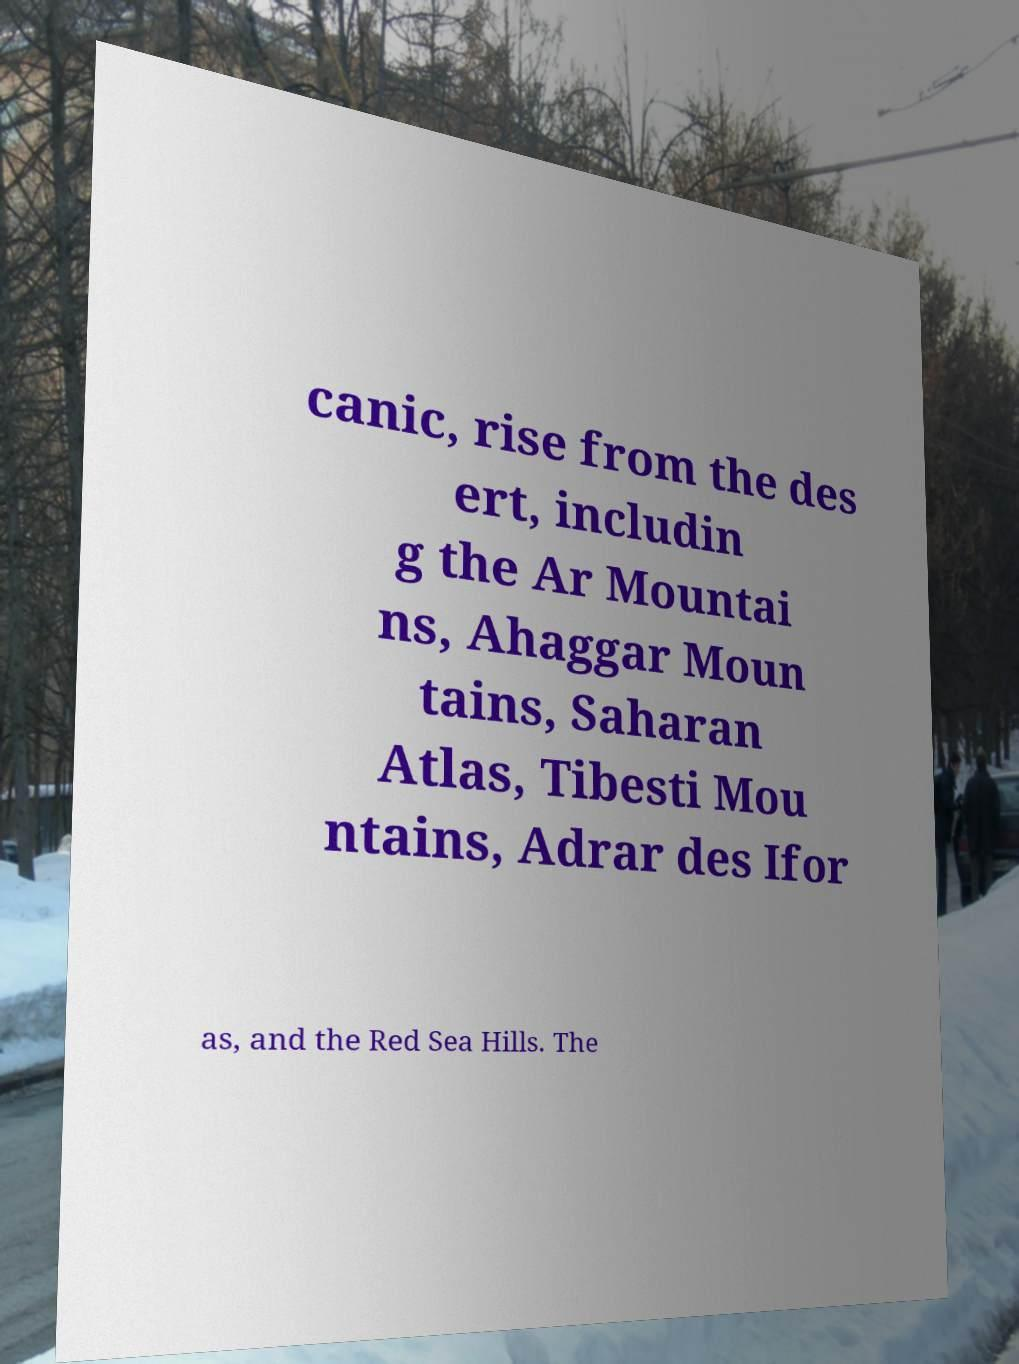There's text embedded in this image that I need extracted. Can you transcribe it verbatim? canic, rise from the des ert, includin g the Ar Mountai ns, Ahaggar Moun tains, Saharan Atlas, Tibesti Mou ntains, Adrar des Ifor as, and the Red Sea Hills. The 